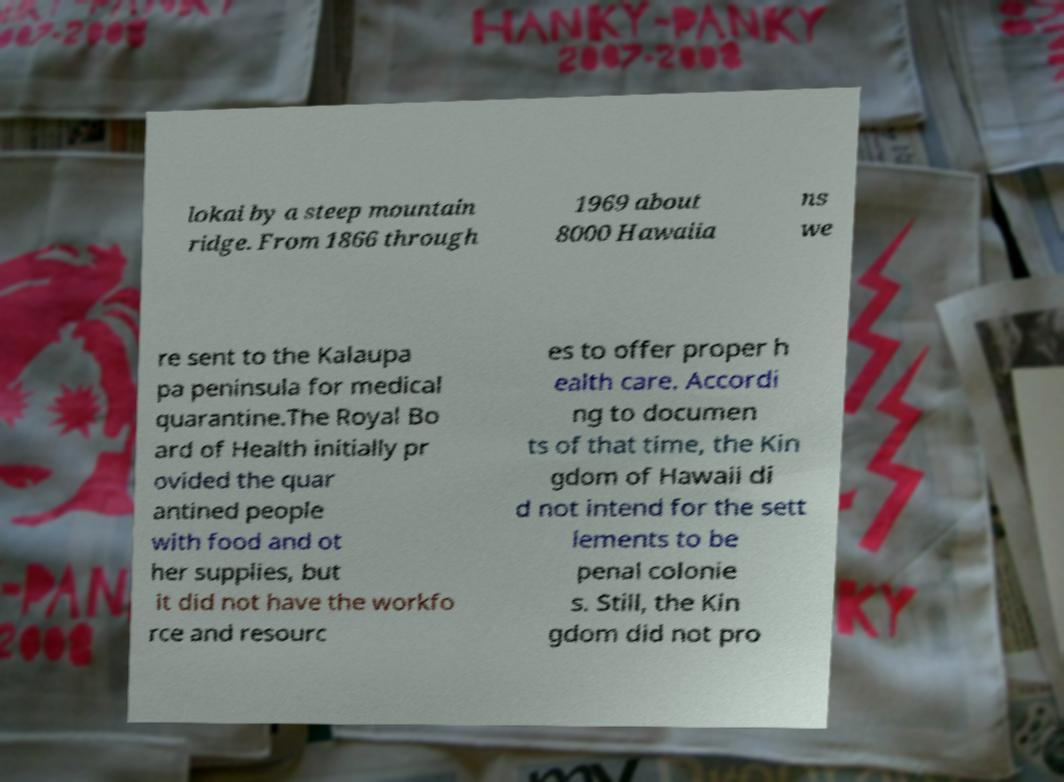Can you accurately transcribe the text from the provided image for me? lokai by a steep mountain ridge. From 1866 through 1969 about 8000 Hawaiia ns we re sent to the Kalaupa pa peninsula for medical quarantine.The Royal Bo ard of Health initially pr ovided the quar antined people with food and ot her supplies, but it did not have the workfo rce and resourc es to offer proper h ealth care. Accordi ng to documen ts of that time, the Kin gdom of Hawaii di d not intend for the sett lements to be penal colonie s. Still, the Kin gdom did not pro 